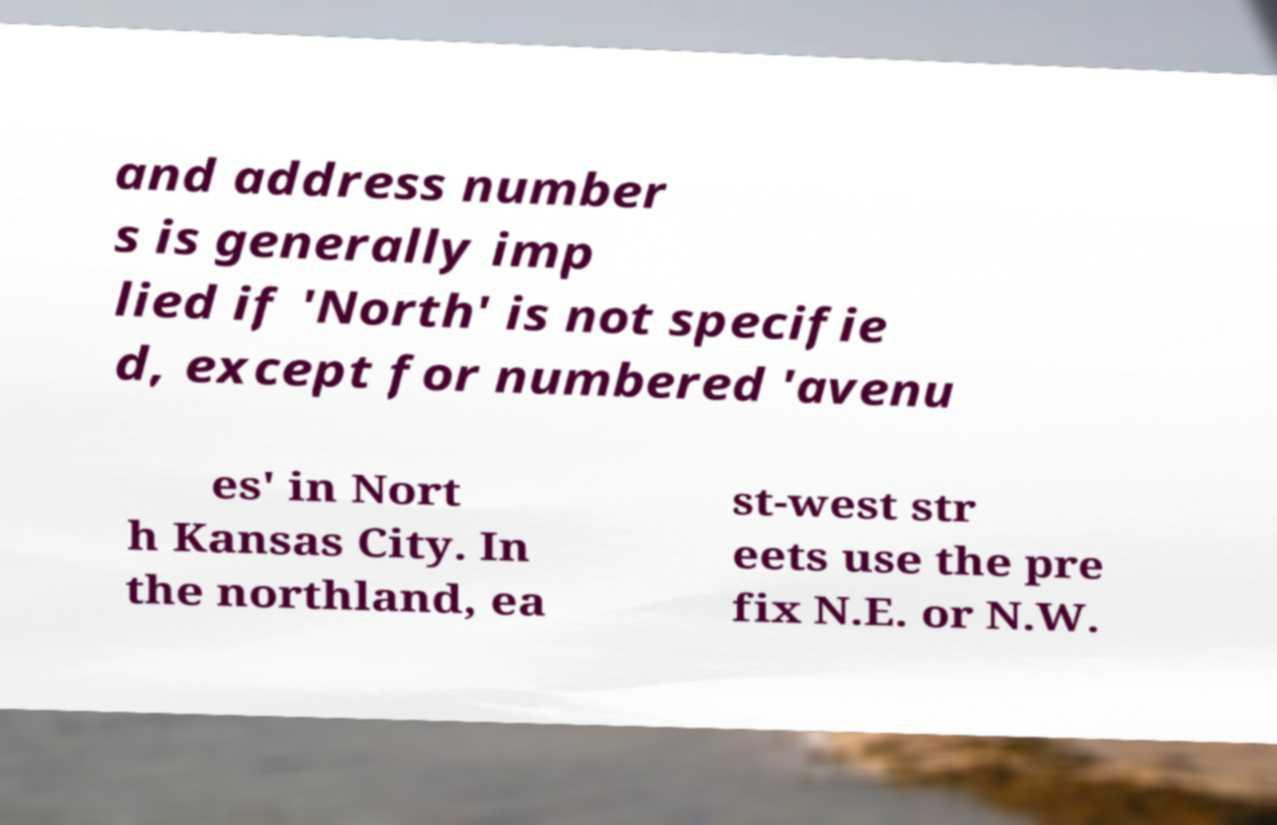Can you accurately transcribe the text from the provided image for me? and address number s is generally imp lied if 'North' is not specifie d, except for numbered 'avenu es' in Nort h Kansas City. In the northland, ea st-west str eets use the pre fix N.E. or N.W. 